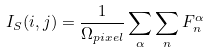Convert formula to latex. <formula><loc_0><loc_0><loc_500><loc_500>I _ { S } ( i , j ) = \frac { 1 } { \Omega _ { p i x e l } } \sum _ { \alpha } \sum _ { n } F _ { n } ^ { \alpha }</formula> 